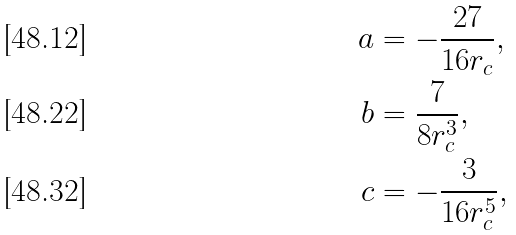<formula> <loc_0><loc_0><loc_500><loc_500>a & = - \frac { 2 7 } { 1 6 r _ { c } } , \\ b & = \frac { 7 } { 8 r _ { c } ^ { 3 } } , \\ c & = - \frac { 3 } { 1 6 r _ { c } ^ { 5 } } ,</formula> 